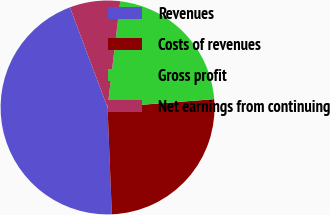Convert chart. <chart><loc_0><loc_0><loc_500><loc_500><pie_chart><fcel>Revenues<fcel>Costs of revenues<fcel>Gross profit<fcel>Net earnings from continuing<nl><fcel>44.92%<fcel>25.6%<fcel>21.87%<fcel>7.61%<nl></chart> 